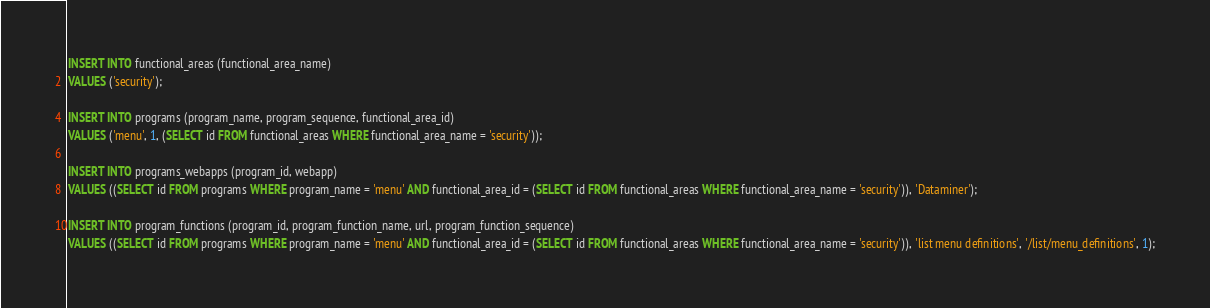Convert code to text. <code><loc_0><loc_0><loc_500><loc_500><_SQL_>INSERT INTO functional_areas (functional_area_name)
VALUES ('security');

INSERT INTO programs (program_name, program_sequence, functional_area_id)
VALUES ('menu', 1, (SELECT id FROM functional_areas WHERE functional_area_name = 'security'));

INSERT INTO programs_webapps (program_id, webapp)
VALUES ((SELECT id FROM programs WHERE program_name = 'menu' AND functional_area_id = (SELECT id FROM functional_areas WHERE functional_area_name = 'security')), 'Dataminer');

INSERT INTO program_functions (program_id, program_function_name, url, program_function_sequence)
VALUES ((SELECT id FROM programs WHERE program_name = 'menu' AND functional_area_id = (SELECT id FROM functional_areas WHERE functional_area_name = 'security')), 'list menu definitions', '/list/menu_definitions', 1);

</code> 